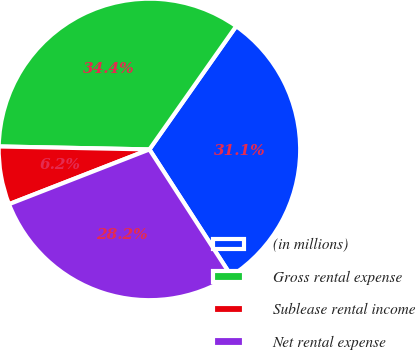Convert chart. <chart><loc_0><loc_0><loc_500><loc_500><pie_chart><fcel>(in millions)<fcel>Gross rental expense<fcel>Sublease rental income<fcel>Net rental expense<nl><fcel>31.1%<fcel>34.45%<fcel>6.23%<fcel>28.22%<nl></chart> 